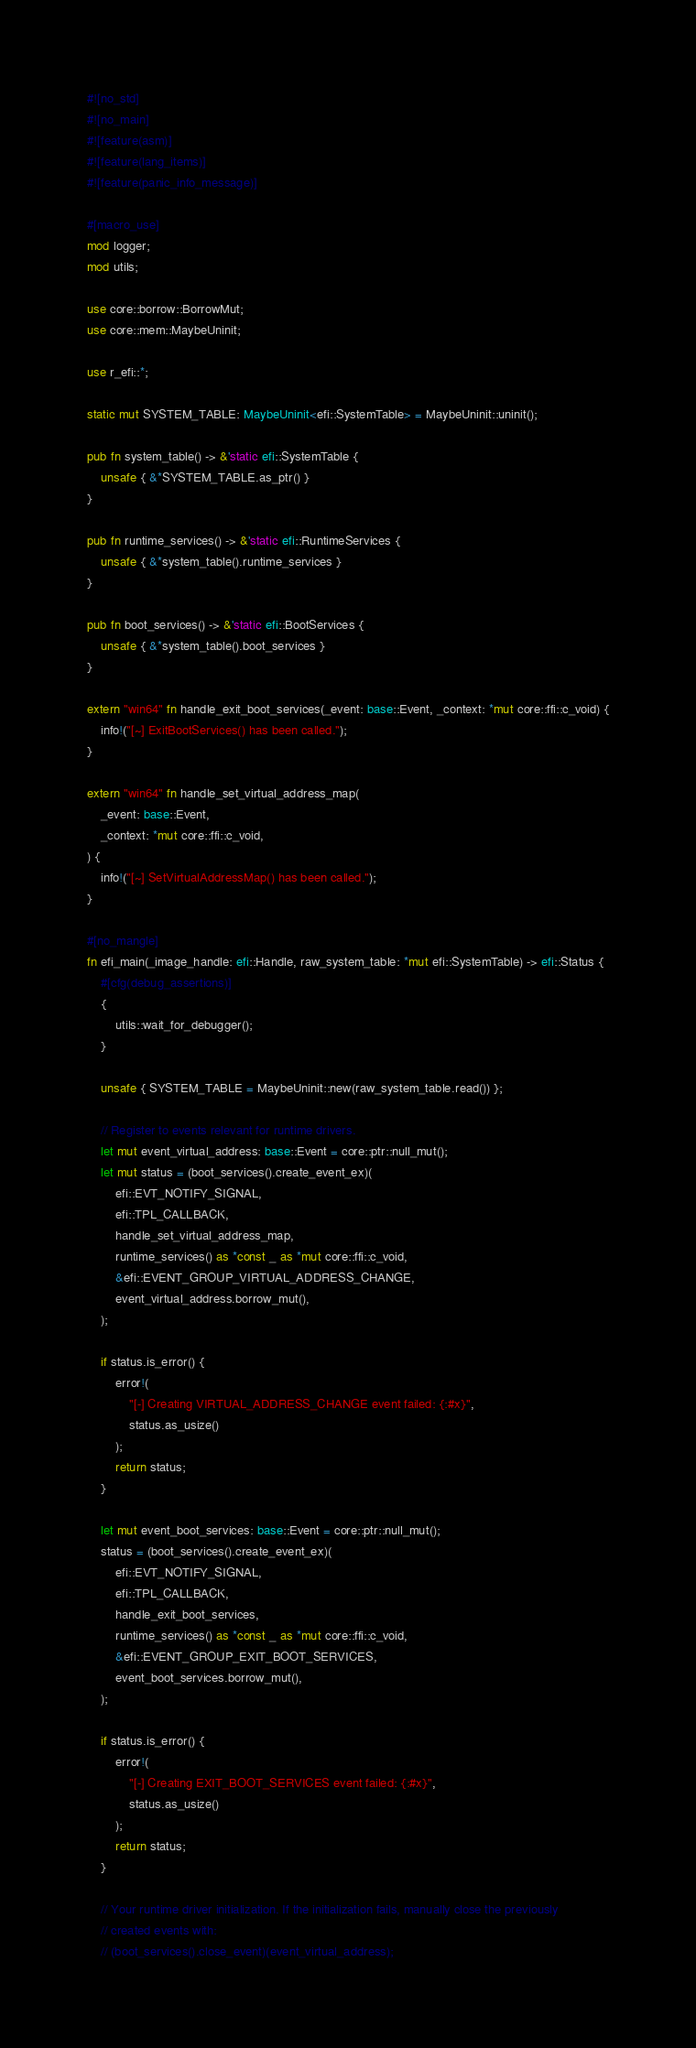<code> <loc_0><loc_0><loc_500><loc_500><_Rust_>#![no_std]
#![no_main]
#![feature(asm)]
#![feature(lang_items)]
#![feature(panic_info_message)]

#[macro_use]
mod logger;
mod utils;

use core::borrow::BorrowMut;
use core::mem::MaybeUninit;

use r_efi::*;

static mut SYSTEM_TABLE: MaybeUninit<efi::SystemTable> = MaybeUninit::uninit();

pub fn system_table() -> &'static efi::SystemTable {
    unsafe { &*SYSTEM_TABLE.as_ptr() }
}

pub fn runtime_services() -> &'static efi::RuntimeServices {
    unsafe { &*system_table().runtime_services }
}

pub fn boot_services() -> &'static efi::BootServices {
    unsafe { &*system_table().boot_services }
}

extern "win64" fn handle_exit_boot_services(_event: base::Event, _context: *mut core::ffi::c_void) {
    info!("[~] ExitBootServices() has been called.");
}

extern "win64" fn handle_set_virtual_address_map(
    _event: base::Event,
    _context: *mut core::ffi::c_void,
) {
    info!("[~] SetVirtualAddressMap() has been called.");
}

#[no_mangle]
fn efi_main(_image_handle: efi::Handle, raw_system_table: *mut efi::SystemTable) -> efi::Status {
    #[cfg(debug_assertions)]
    {
        utils::wait_for_debugger();
    }

    unsafe { SYSTEM_TABLE = MaybeUninit::new(raw_system_table.read()) };

    // Register to events relevant for runtime drivers.
    let mut event_virtual_address: base::Event = core::ptr::null_mut();
    let mut status = (boot_services().create_event_ex)(
        efi::EVT_NOTIFY_SIGNAL,
        efi::TPL_CALLBACK,
        handle_set_virtual_address_map,
        runtime_services() as *const _ as *mut core::ffi::c_void,
        &efi::EVENT_GROUP_VIRTUAL_ADDRESS_CHANGE,
        event_virtual_address.borrow_mut(),
    );

    if status.is_error() {
        error!(
            "[-] Creating VIRTUAL_ADDRESS_CHANGE event failed: {:#x}",
            status.as_usize()
        );
        return status;
    }

    let mut event_boot_services: base::Event = core::ptr::null_mut();
    status = (boot_services().create_event_ex)(
        efi::EVT_NOTIFY_SIGNAL,
        efi::TPL_CALLBACK,
        handle_exit_boot_services,
        runtime_services() as *const _ as *mut core::ffi::c_void,
        &efi::EVENT_GROUP_EXIT_BOOT_SERVICES,
        event_boot_services.borrow_mut(),
    );

    if status.is_error() {
        error!(
            "[-] Creating EXIT_BOOT_SERVICES event failed: {:#x}",
            status.as_usize()
        );
        return status;
    }

    // Your runtime driver initialization. If the initialization fails, manually close the previously
    // created events with:
    // (boot_services().close_event)(event_virtual_address);</code> 